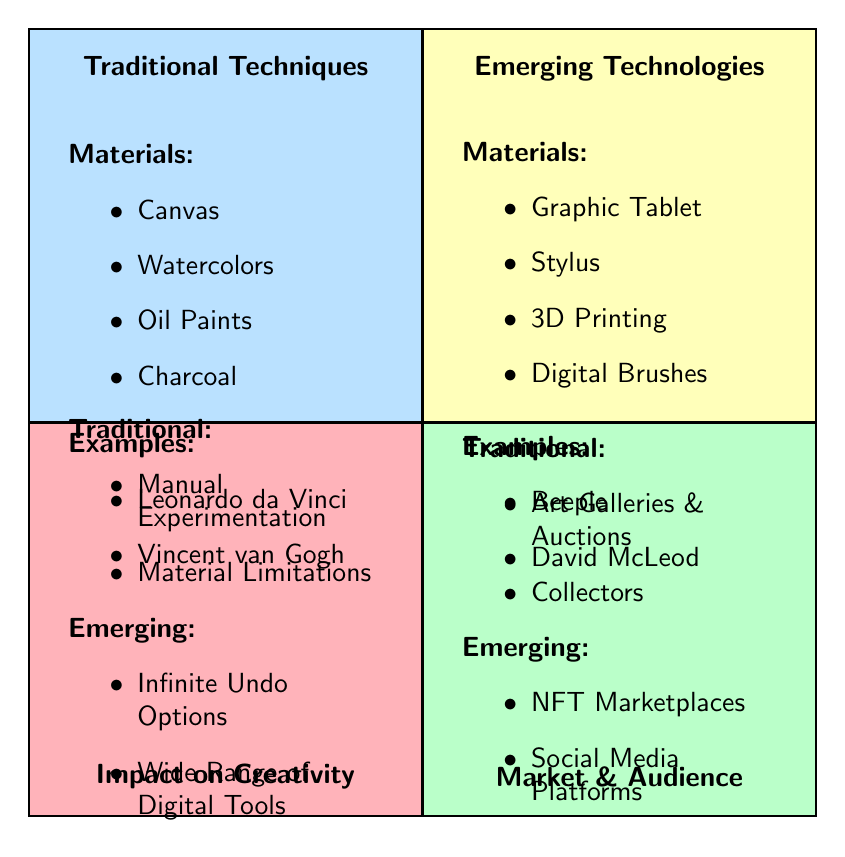What are the materials listed for Traditional Techniques? The diagram specifies four materials under Traditional Techniques: Canvas, Watercolors, Oil Paints, and Charcoal. This information can be found in the respective quadrant where the materials are explicitly stated.
Answer: Canvas, Watercolors, Oil Paints, Charcoal Which artist is associated with Emerging Technologies? In the Emerging Technologies quadrant, Beeple is named as an associated artist, along with his artworks. This is derived from the examples listed under that category.
Answer: Beeple How many skillsets are listed under Emerging Technologies? The Emerging Technologies quadrant lists four skillsets: Digital Illustration, 3D Modeling, Texturing, and Motion Graphics. By counting the bullet points, I can ascertain that there are four skillsets.
Answer: 4 What is the primary characteristic of the Market & Audience for Traditional Techniques? The Market & Audience quadrant for Traditional Techniques identifies several aspects, with Art Galleries & Auctions being a prominent feature. This is evident from the items listed in that section.
Answer: Art Galleries & Auctions What are the intangible outcomes of Emerging Technologies? The Emerging Technologies quadrant lists four outcomes, among which "Infinite Undo Options" stands out as it emphasizes the digital environment's flexibility. This conclusion comes from the specified outcomes in that quadrant.
Answer: Infinite Undo Options Which technique emphasizes Artisan Craftsmanship? The parameter for Impact on Creativity in Traditional Techniques highlights Artisan Craftsmanship as a key feature. This information is found in the relevant section that details traditional artistic values.
Answer: Artisan Craftsmanship What tools are highlighted in Emerging Technologies for digital creation? The materials listed in the Emerging Technologies quadrant begin with Graphic Tablet and Stylus, which are essential tools in modern digital creation. This can be gathered from the provided materials in that area.
Answer: Graphic Tablet, Stylus Which art form tends to have a perception of timeless value? The description in the Impact on Creativity section mentions "Timeless Value" explicitly, relating it to Traditional Techniques. This is directly stated in the examples provided in that quadrant.
Answer: Timeless Value What is one example of a market platform for Traditional Techniques? The diagram presents Christie's Auction House as a specific example of a market platform for Traditional Techniques, linking it to notable auction events described. This is derived from the respective examples in the Market & Audience section.
Answer: Christie's Auction House 